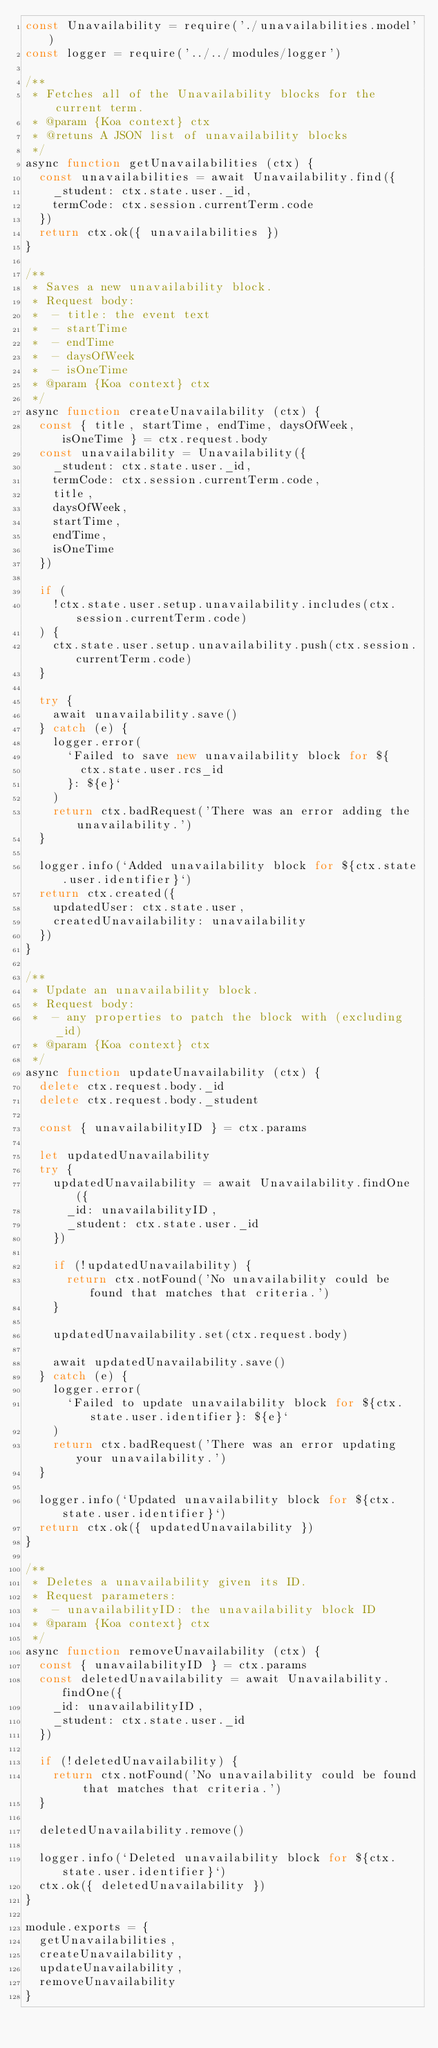Convert code to text. <code><loc_0><loc_0><loc_500><loc_500><_JavaScript_>const Unavailability = require('./unavailabilities.model')
const logger = require('../../modules/logger')

/**
 * Fetches all of the Unavailability blocks for the current term.
 * @param {Koa context} ctx
 * @retuns A JSON list of unavailability blocks
 */
async function getUnavailabilities (ctx) {
  const unavailabilities = await Unavailability.find({
    _student: ctx.state.user._id,
    termCode: ctx.session.currentTerm.code
  })
  return ctx.ok({ unavailabilities })
}

/**
 * Saves a new unavailability block.
 * Request body:
 *  - title: the event text
 *  - startTime
 *  - endTime
 *  - daysOfWeek
 *  - isOneTime
 * @param {Koa context} ctx
 */
async function createUnavailability (ctx) {
  const { title, startTime, endTime, daysOfWeek, isOneTime } = ctx.request.body
  const unavailability = Unavailability({
    _student: ctx.state.user._id,
    termCode: ctx.session.currentTerm.code,
    title,
    daysOfWeek,
    startTime,
    endTime,
    isOneTime
  })

  if (
    !ctx.state.user.setup.unavailability.includes(ctx.session.currentTerm.code)
  ) {
    ctx.state.user.setup.unavailability.push(ctx.session.currentTerm.code)
  }

  try {
    await unavailability.save()
  } catch (e) {
    logger.error(
      `Failed to save new unavailability block for ${
        ctx.state.user.rcs_id
      }: ${e}`
    )
    return ctx.badRequest('There was an error adding the unavailability.')
  }

  logger.info(`Added unavailability block for ${ctx.state.user.identifier}`)
  return ctx.created({
    updatedUser: ctx.state.user,
    createdUnavailability: unavailability
  })
}

/**
 * Update an unavailability block.
 * Request body:
 *  - any properties to patch the block with (excluding _id)
 * @param {Koa context} ctx
 */
async function updateUnavailability (ctx) {
  delete ctx.request.body._id
  delete ctx.request.body._student

  const { unavailabilityID } = ctx.params

  let updatedUnavailability
  try {
    updatedUnavailability = await Unavailability.findOne({
      _id: unavailabilityID,
      _student: ctx.state.user._id
    })

    if (!updatedUnavailability) {
      return ctx.notFound('No unavailability could be found that matches that criteria.')
    }

    updatedUnavailability.set(ctx.request.body)

    await updatedUnavailability.save()
  } catch (e) {
    logger.error(
      `Failed to update unavailability block for ${ctx.state.user.identifier}: ${e}`
    )
    return ctx.badRequest('There was an error updating your unavailability.')
  }

  logger.info(`Updated unavailability block for ${ctx.state.user.identifier}`)
  return ctx.ok({ updatedUnavailability })
}

/**
 * Deletes a unavailability given its ID.
 * Request parameters:
 *  - unavailabilityID: the unavailability block ID
 * @param {Koa context} ctx
 */
async function removeUnavailability (ctx) {
  const { unavailabilityID } = ctx.params
  const deletedUnavailability = await Unavailability.findOne({
    _id: unavailabilityID,
    _student: ctx.state.user._id
  })

  if (!deletedUnavailability) {
    return ctx.notFound('No unavailability could be found that matches that criteria.')
  }

  deletedUnavailability.remove()

  logger.info(`Deleted unavailability block for ${ctx.state.user.identifier}`)
  ctx.ok({ deletedUnavailability })
}

module.exports = {
  getUnavailabilities,
  createUnavailability,
  updateUnavailability,
  removeUnavailability
}
</code> 